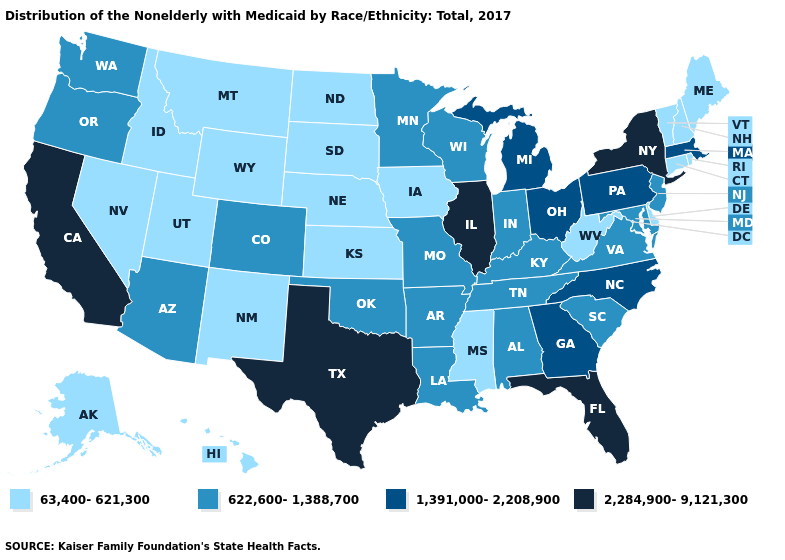Among the states that border Washington , does Idaho have the highest value?
Give a very brief answer. No. What is the lowest value in states that border Pennsylvania?
Short answer required. 63,400-621,300. Name the states that have a value in the range 622,600-1,388,700?
Concise answer only. Alabama, Arizona, Arkansas, Colorado, Indiana, Kentucky, Louisiana, Maryland, Minnesota, Missouri, New Jersey, Oklahoma, Oregon, South Carolina, Tennessee, Virginia, Washington, Wisconsin. Which states have the lowest value in the USA?
Be succinct. Alaska, Connecticut, Delaware, Hawaii, Idaho, Iowa, Kansas, Maine, Mississippi, Montana, Nebraska, Nevada, New Hampshire, New Mexico, North Dakota, Rhode Island, South Dakota, Utah, Vermont, West Virginia, Wyoming. Name the states that have a value in the range 622,600-1,388,700?
Concise answer only. Alabama, Arizona, Arkansas, Colorado, Indiana, Kentucky, Louisiana, Maryland, Minnesota, Missouri, New Jersey, Oklahoma, Oregon, South Carolina, Tennessee, Virginia, Washington, Wisconsin. Name the states that have a value in the range 63,400-621,300?
Be succinct. Alaska, Connecticut, Delaware, Hawaii, Idaho, Iowa, Kansas, Maine, Mississippi, Montana, Nebraska, Nevada, New Hampshire, New Mexico, North Dakota, Rhode Island, South Dakota, Utah, Vermont, West Virginia, Wyoming. Does Montana have the lowest value in the USA?
Give a very brief answer. Yes. Does Connecticut have the highest value in the USA?
Keep it brief. No. Is the legend a continuous bar?
Keep it brief. No. Name the states that have a value in the range 1,391,000-2,208,900?
Give a very brief answer. Georgia, Massachusetts, Michigan, North Carolina, Ohio, Pennsylvania. Which states have the lowest value in the USA?
Answer briefly. Alaska, Connecticut, Delaware, Hawaii, Idaho, Iowa, Kansas, Maine, Mississippi, Montana, Nebraska, Nevada, New Hampshire, New Mexico, North Dakota, Rhode Island, South Dakota, Utah, Vermont, West Virginia, Wyoming. Does the first symbol in the legend represent the smallest category?
Give a very brief answer. Yes. What is the highest value in the West ?
Keep it brief. 2,284,900-9,121,300. 